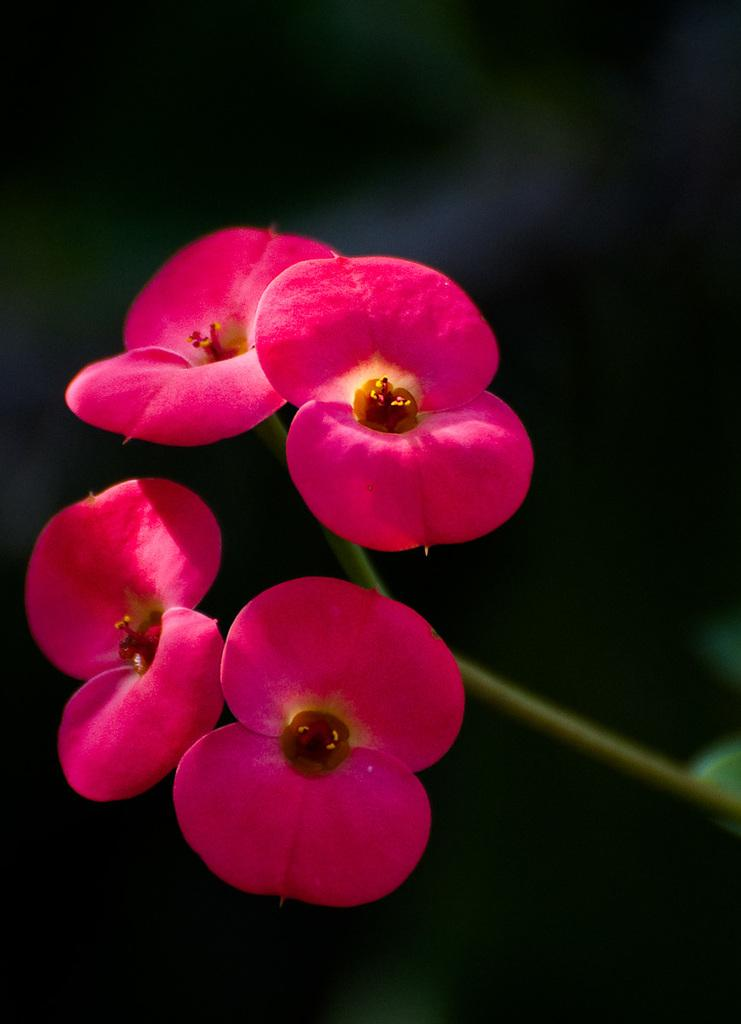What type of living organisms can be seen in the image? There are flowers in the image. Can you describe the background of the image? The background of the image is blurred. What type of mitten can be seen on the tongue of the flower in the image? There is no mitten or tongue present in the image, as flowers do not have tongues or wear mittens. 